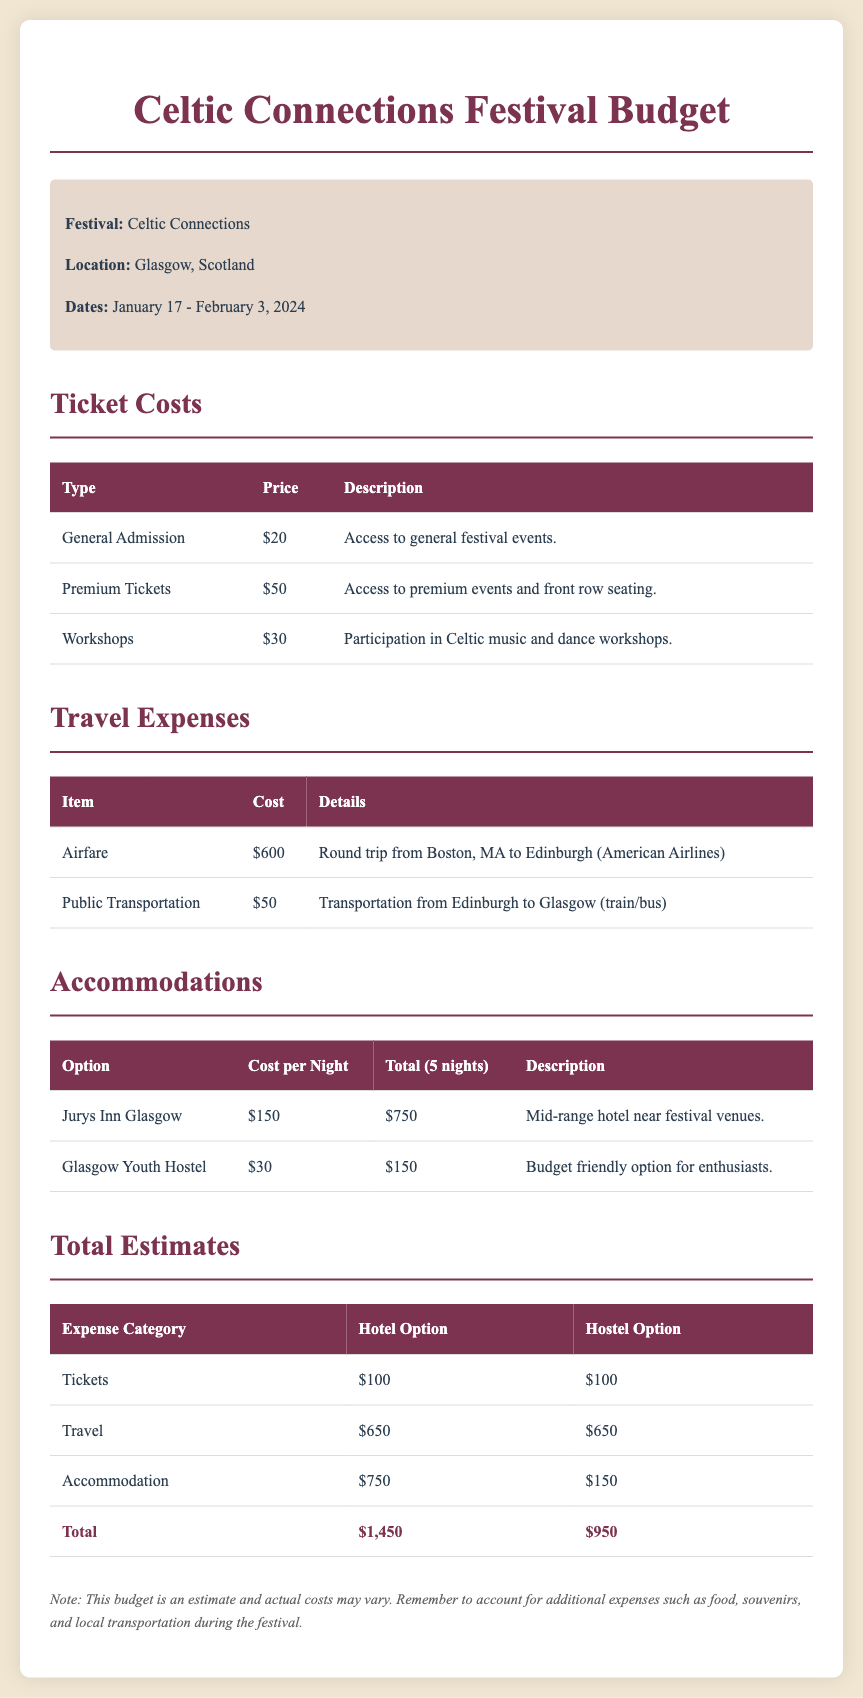What are the festival dates? The festival dates are listed directly in the document, which specifies January 17 - February 3, 2024.
Answer: January 17 - February 3, 2024 How much is a Premium Ticket? The cost of a Premium Ticket is mentioned in the ticket costs section of the document, which states it is $50.
Answer: $50 What is the total cost of staying at Jurys Inn Glasgow for 5 nights? The total cost for staying at Jurys Inn Glasgow is calculated based on the nightly rate of $150 for 5 nights, totaling $750.
Answer: $750 What is the airfare expense? The airfare expense is provided in the travel expenses section, showing it as $600 for a round trip.
Answer: $600 How much more expensive is staying at Jurys Inn compared to Glasgow Youth Hostel? The total costs for Jurys Inn and Glasgow Youth Hostel are $750 and $150 respectively, resulting in a difference of $600.
Answer: $600 What is the total estimated cost for the hostel option? The total estimated cost for the hostel option is calculated from the tickets, travel, and accommodation costs listed, resulting in $950.
Answer: $950 What mode of transportation is used from Edinburgh to Glasgow? The document specifies that public transportation is used for travel between these cities.
Answer: Public Transportation What is included in the Workshops ticket? The description for the Workshops ticket states that it includes participation in Celtic music and dance workshops.
Answer: Participation in Celtic music and dance workshops What is the total ticket cost? The total ticket costs are given as $100 for both hotel and hostel options, which is derived from adding the tickets listed in the table.
Answer: $100 